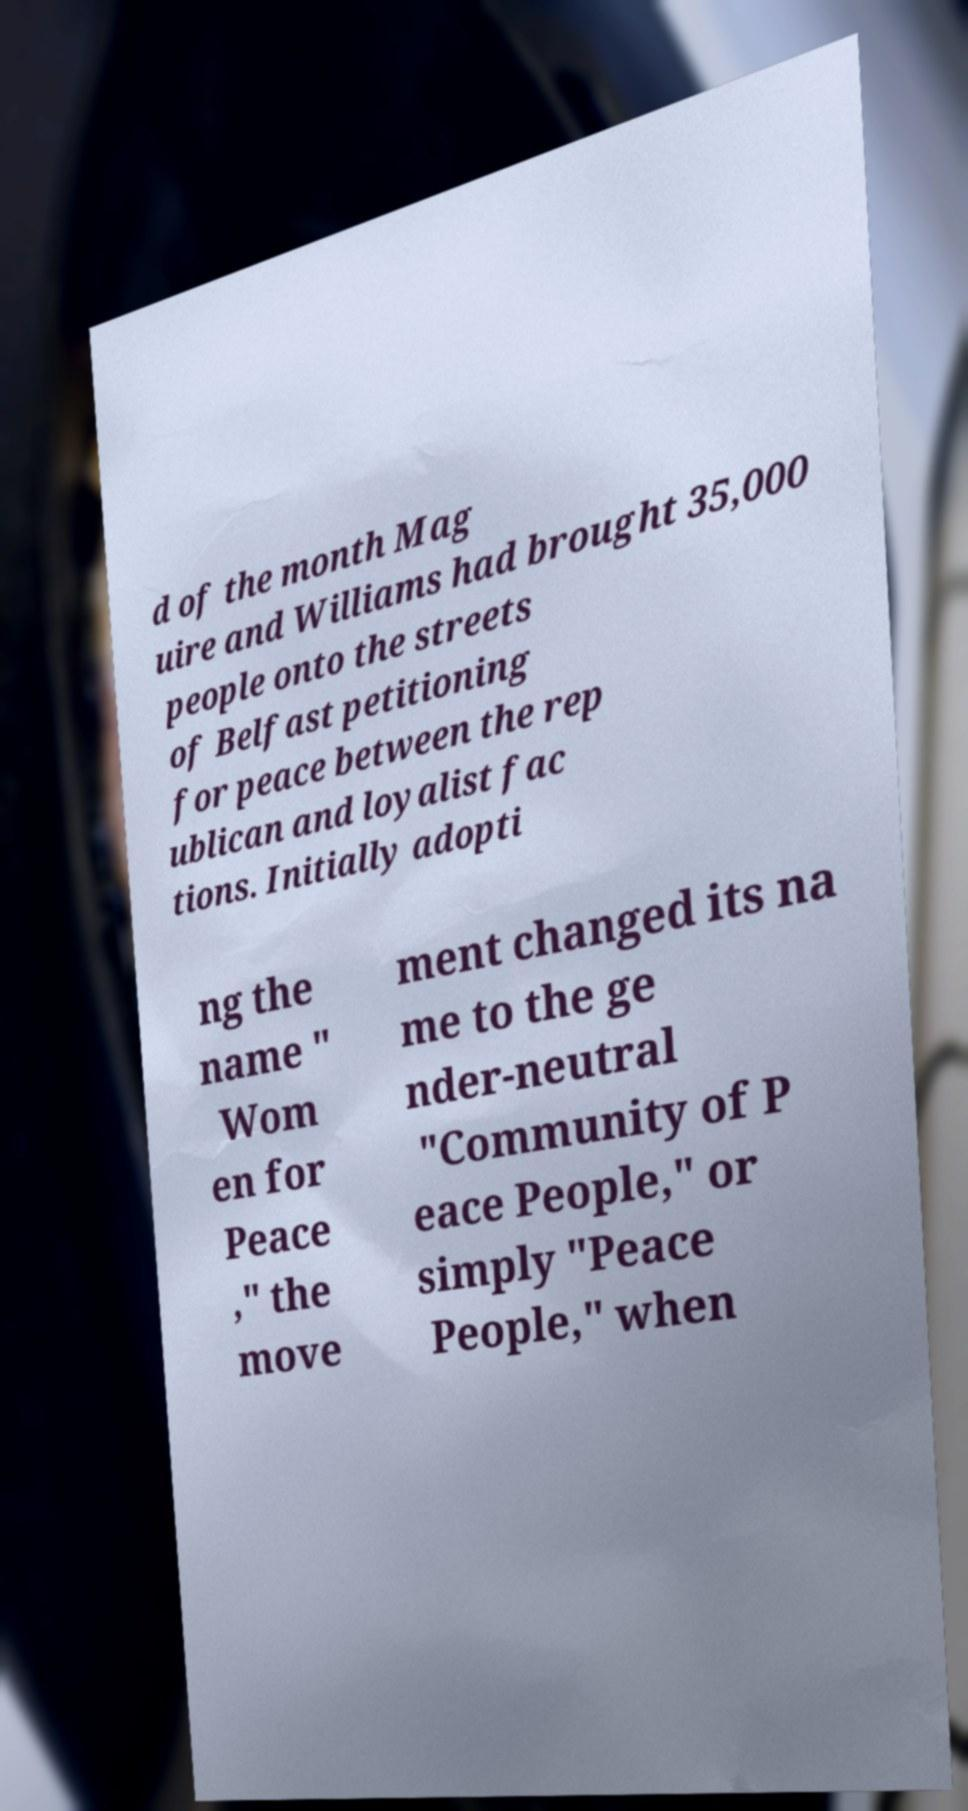Please read and relay the text visible in this image. What does it say? d of the month Mag uire and Williams had brought 35,000 people onto the streets of Belfast petitioning for peace between the rep ublican and loyalist fac tions. Initially adopti ng the name " Wom en for Peace ," the move ment changed its na me to the ge nder-neutral "Community of P eace People," or simply "Peace People," when 